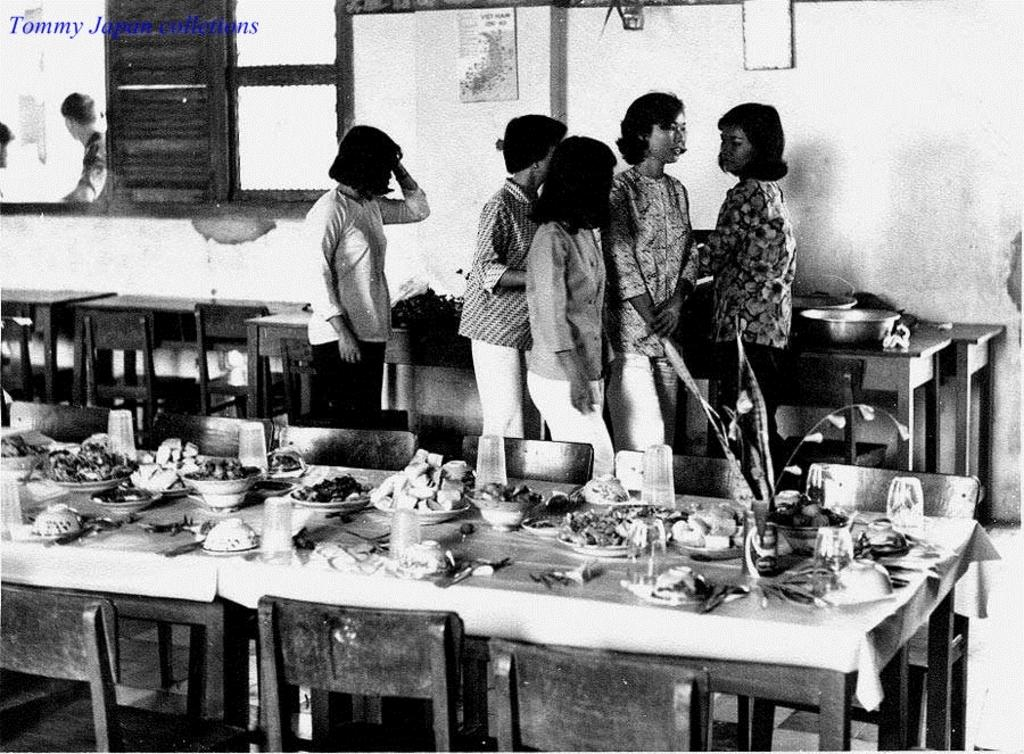How many people are in the image? There is a group of people in the image, but the exact number cannot be determined from the provided facts. What is on the table in the image? There is a glass, a plate, a bowl, fruits, and food items on the table in the image. What can be seen in the background of the image? There is a window, a poster on the wall, and a wall visible in the background of the image. Where is the dock located in the image? There is no dock present in the image. What type of dogs can be seen playing in the front of the image? There are no dogs present in the image. 